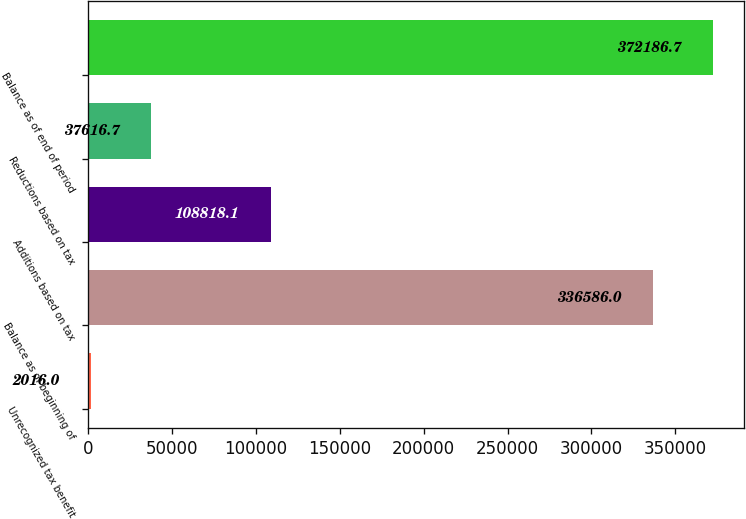Convert chart. <chart><loc_0><loc_0><loc_500><loc_500><bar_chart><fcel>Unrecognized tax benefit<fcel>Balance as of beginning of<fcel>Additions based on tax<fcel>Reductions based on tax<fcel>Balance as of end of period<nl><fcel>2016<fcel>336586<fcel>108818<fcel>37616.7<fcel>372187<nl></chart> 